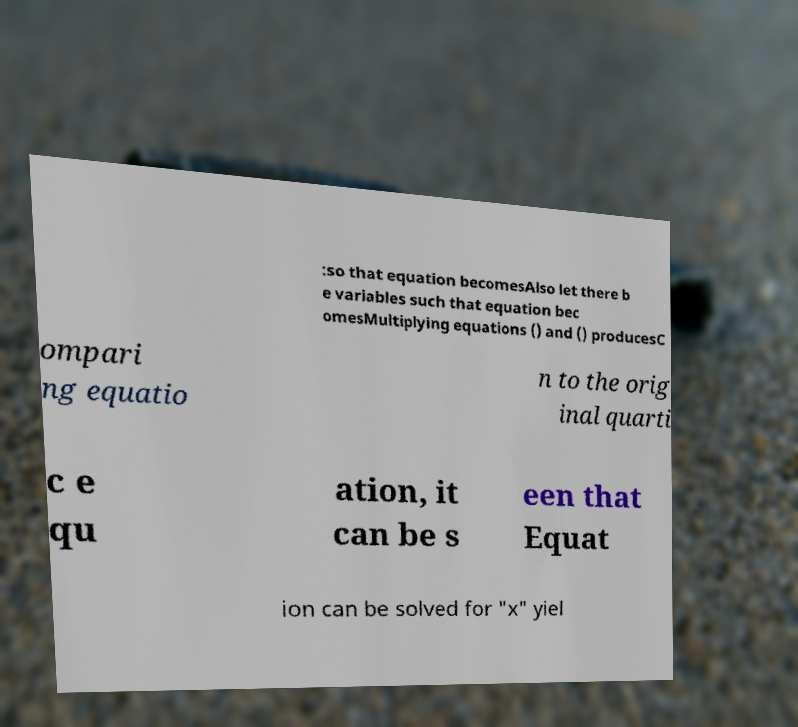Please identify and transcribe the text found in this image. :so that equation becomesAlso let there b e variables such that equation bec omesMultiplying equations () and () producesC ompari ng equatio n to the orig inal quarti c e qu ation, it can be s een that Equat ion can be solved for "x" yiel 